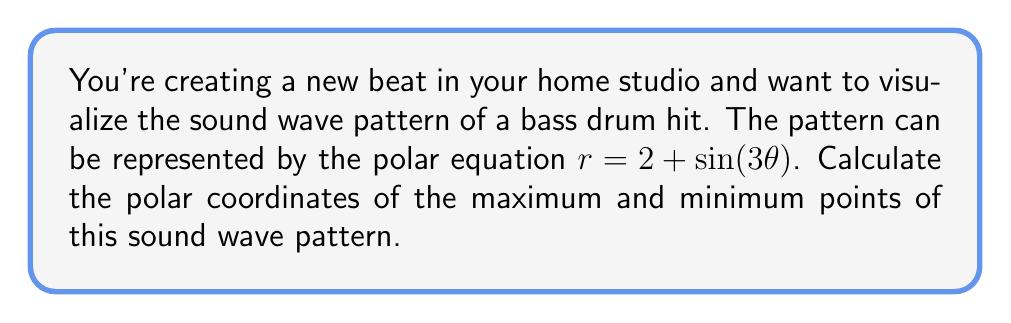Can you solve this math problem? To find the maximum and minimum points of the sound wave pattern, we need to follow these steps:

1) The equation $r = 2 + \sin(3\theta)$ represents a rose curve with 3 petals.

2) The maximum points occur when $\sin(3\theta) = 1$, and the minimum points occur when $\sin(3\theta) = -1$.

3) For maximum points:
   $\sin(3\theta) = 1$
   $3\theta = \frac{\pi}{2}, \frac{5\pi}{2}, \frac{9\pi}{2}$
   $\theta = \frac{\pi}{6}, \frac{5\pi}{6}, \frac{3\pi}{2}$

4) For minimum points:
   $\sin(3\theta) = -1$
   $3\theta = \frac{3\pi}{2}, \frac{7\pi}{2}, \frac{11\pi}{2}$
   $\theta = \frac{\pi}{2}, \frac{7\pi}{6}, \frac{11\pi}{6}$

5) Calculate $r$ for maximum points:
   $r_{max} = 2 + \sin(3\theta) = 2 + 1 = 3$

6) Calculate $r$ for minimum points:
   $r_{min} = 2 + \sin(3\theta) = 2 - 1 = 1$

7) The polar coordinates are $(r, \theta)$ pairs.

Therefore, the maximum points are:
$$(3, \frac{\pi}{6}), (3, \frac{5\pi}{6}), (3, \frac{3\pi}{2})$$

And the minimum points are:
$$(1, \frac{\pi}{2}), (1, \frac{7\pi}{6}), (1, \frac{11\pi}{6})$$
Answer: Maximum points: $(3, \frac{\pi}{6}), (3, \frac{5\pi}{6}), (3, \frac{3\pi}{2})$
Minimum points: $(1, \frac{\pi}{2}), (1, \frac{7\pi}{6}), (1, \frac{11\pi}{6})$ 